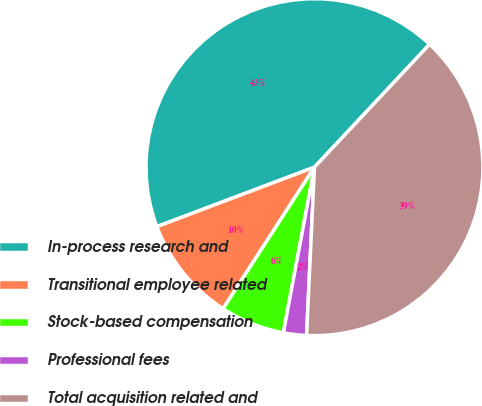<chart> <loc_0><loc_0><loc_500><loc_500><pie_chart><fcel>In-process research and<fcel>Transitional employee related<fcel>Stock-based compensation<fcel>Professional fees<fcel>Total acquisition related and<nl><fcel>42.72%<fcel>10.13%<fcel>6.17%<fcel>2.21%<fcel>38.76%<nl></chart> 